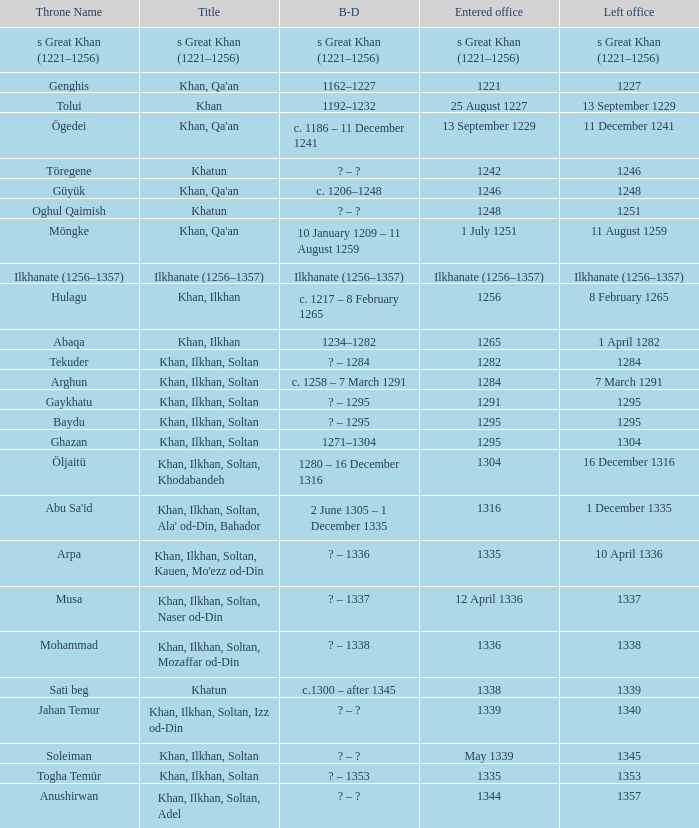What is the entered office that has 1337 as the left office? 12 April 1336. 